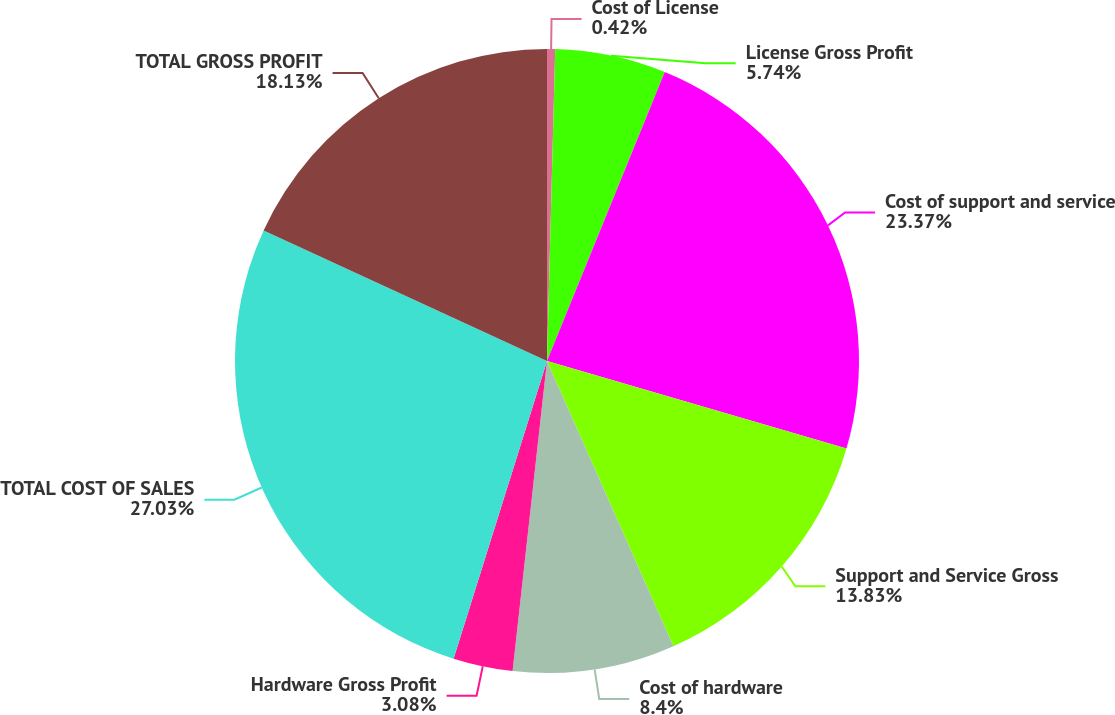<chart> <loc_0><loc_0><loc_500><loc_500><pie_chart><fcel>Cost of License<fcel>License Gross Profit<fcel>Cost of support and service<fcel>Support and Service Gross<fcel>Cost of hardware<fcel>Hardware Gross Profit<fcel>TOTAL COST OF SALES<fcel>TOTAL GROSS PROFIT<nl><fcel>0.42%<fcel>5.74%<fcel>23.37%<fcel>13.83%<fcel>8.4%<fcel>3.08%<fcel>27.03%<fcel>18.13%<nl></chart> 